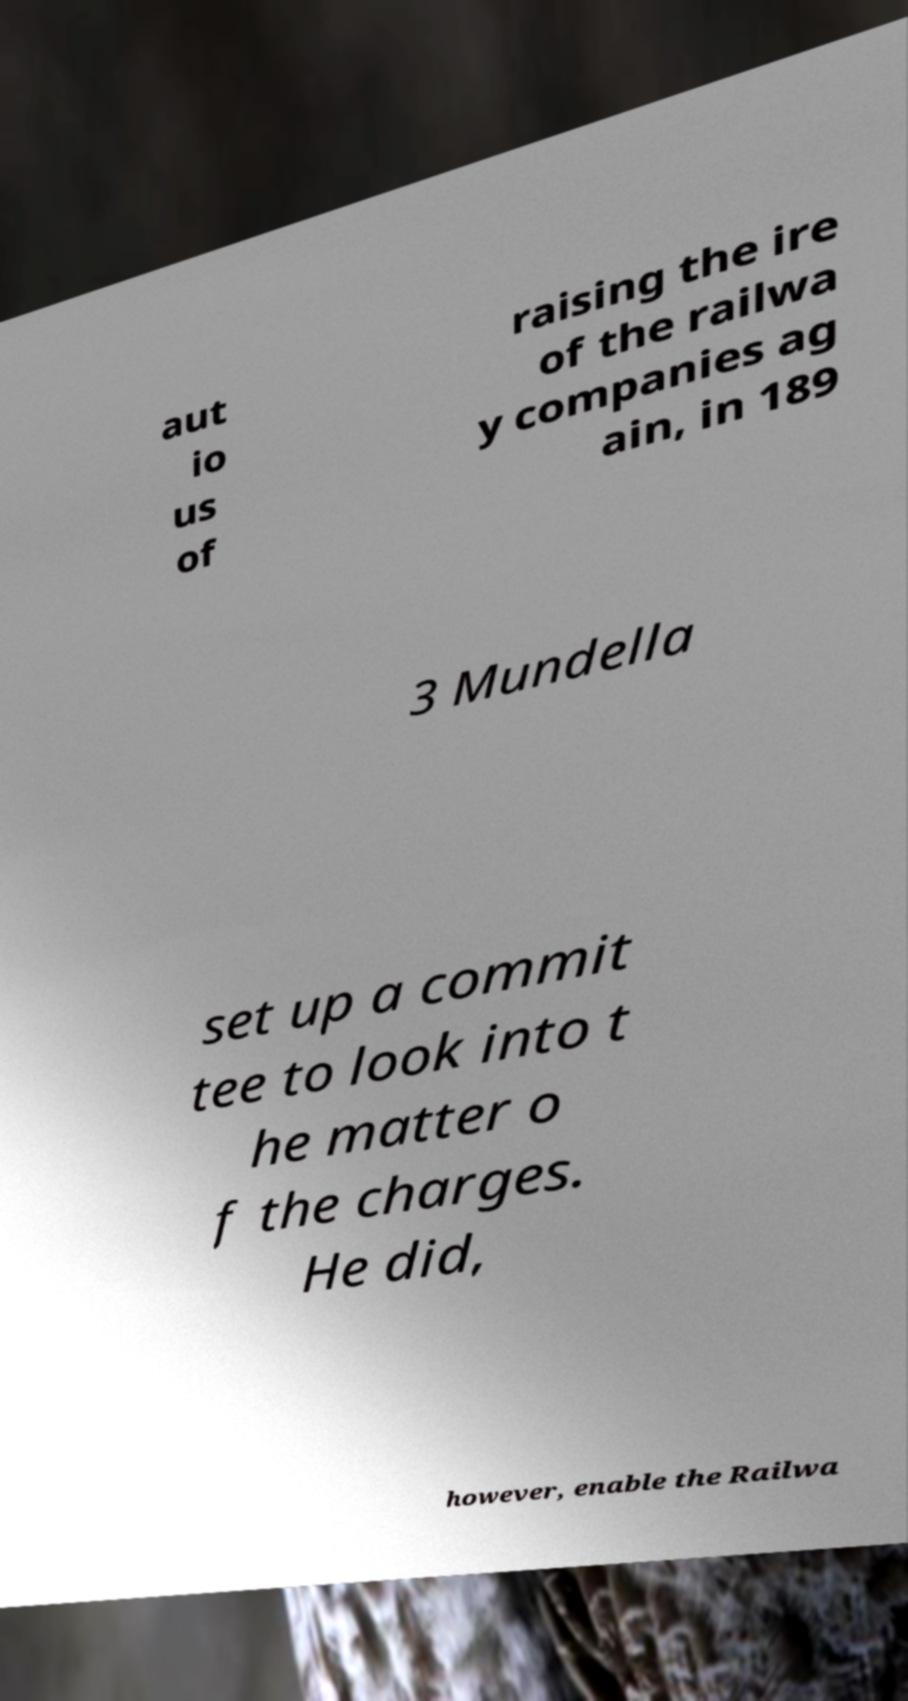There's text embedded in this image that I need extracted. Can you transcribe it verbatim? aut io us of raising the ire of the railwa y companies ag ain, in 189 3 Mundella set up a commit tee to look into t he matter o f the charges. He did, however, enable the Railwa 